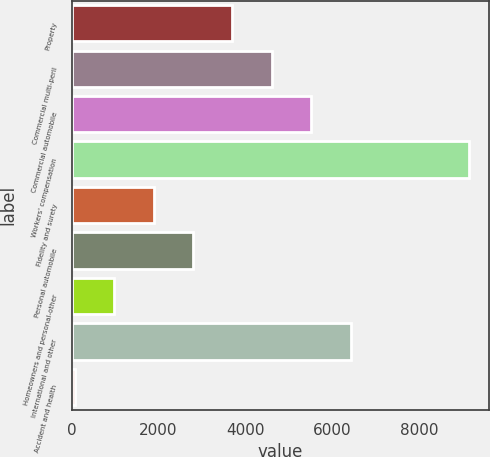<chart> <loc_0><loc_0><loc_500><loc_500><bar_chart><fcel>Property<fcel>Commercial multi-peril<fcel>Commercial automobile<fcel>Workers' compensation<fcel>Fidelity and surety<fcel>Personal automobile<fcel>Homeowners and personal-other<fcel>International and other<fcel>Accident and health<nl><fcel>3702.4<fcel>4609<fcel>5515.6<fcel>9142<fcel>1889.2<fcel>2795.8<fcel>982.6<fcel>6422.2<fcel>76<nl></chart> 